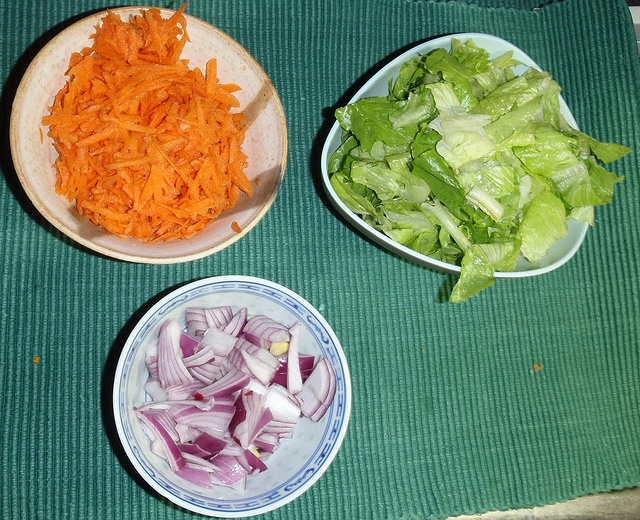Describe the objects in this image and their specific colors. I can see dining table in teal, lightgray, and red tones, bowl in teal, olive, and khaki tones, carrot in teal, red, orange, and brown tones, and carrot in teal, red, orange, and brown tones in this image. 